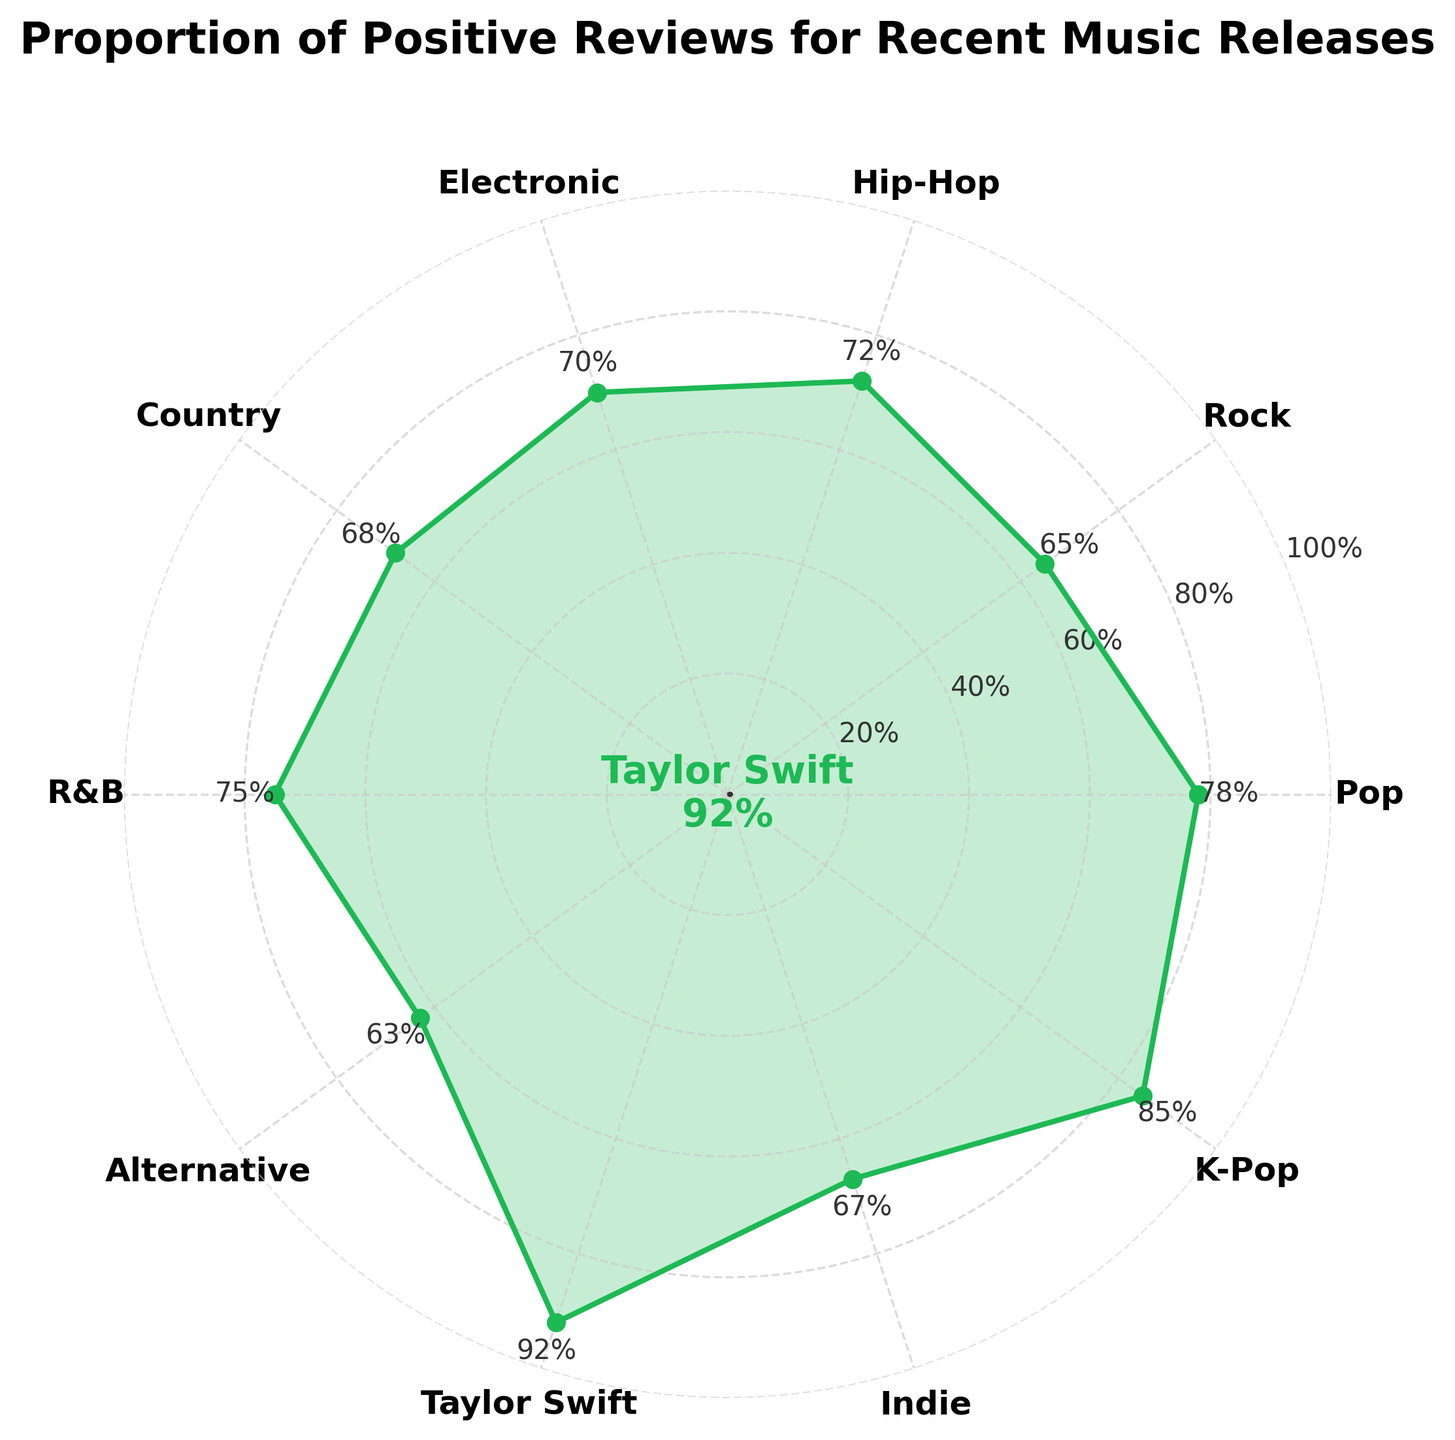What genre has the highest proportion of positive reviews? By looking at the gauge chart, Taylor Swift has the highest proportion of positive reviews at 92%, which is notably higher than any other genre on the chart.
Answer: Taylor Swift What is the positive review percentage for Hip-Hop? The gauge chart clearly shows that the positive review percentage for Hip-Hop is indicated between Rock and Electronic genres. It's marked as 72%.
Answer: 72% Which genre has the lowest proportion of positive reviews? By inspecting the gauge chart, Alternative has the lowest proportion of positive reviews at 63%.
Answer: Alternative How many genres have a positive review percentage above 70%? The genres above 70% are Pop, Hip-Hop, R&B, Taylor Swift, and K-Pop. Counting them gives a total of 5 genres.
Answer: 5 What is the average positive review percentage for the genres Pop, Rock, and Country? Add the percentages of Pop (78), Rock (65), and Country (68), then divide by 3. (78 + 65 + 68) / 3 = 211 / 3 ≈ 70.33
Answer: 70.33 Is the positive review percentage for Electronic greater than that for Country? By comparing the values present on the gauge chart, Electronic has a 70% positive review percentage and Country has 68%. 70% is greater than 68%.
Answer: Yes Compare the positive review percentages of Indie and Alternative genres. Which one is higher and by how much? The gauge chart shows Indie at 67% and Alternative at 63%. The difference between them is 67% - 63% = 4%.
Answer: Indie by 4% What's the median positive review percentage of the genres listed? To find the median, list the percentages in ascending order: 63, 65, 67, 68, 70, 72, 75, 78, 85, 92. The middle values are 70 and 72, so median = (70+72)/2 = 142/2 = 71.
Answer: 71 What color represents the range of 60-80% on the gauge chart? The color for the 60-80% range on the gauge chart is light green (#99FF99, but use natural language, so light green).
Answer: Light green 